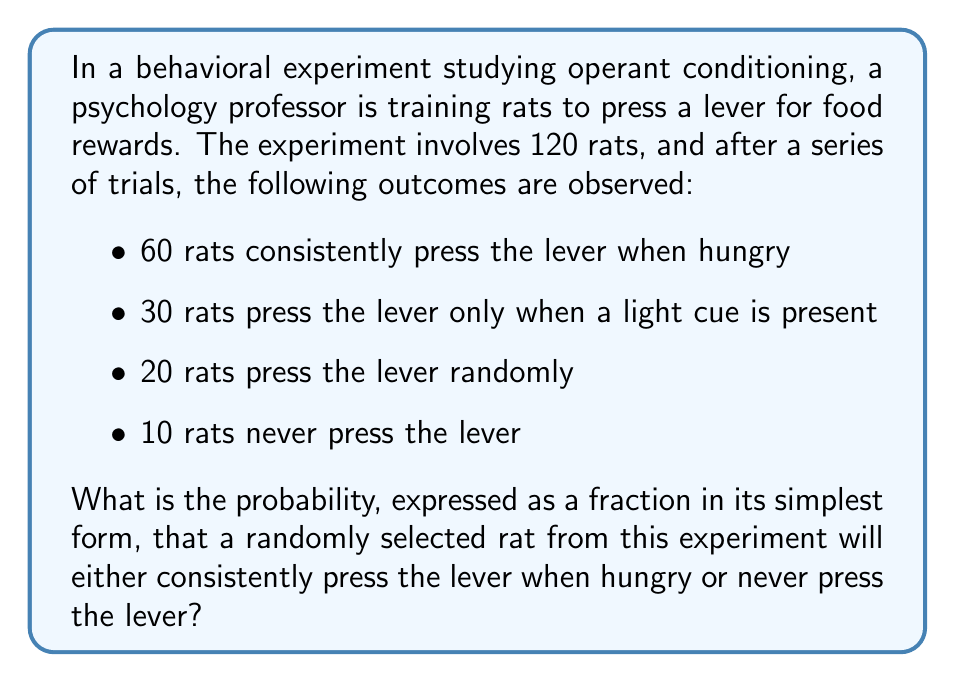Can you solve this math problem? To solve this problem, we need to follow these steps:

1. Identify the total number of rats in the experiment:
   Total rats = 120

2. Identify the number of rats that meet our criteria:
   - Rats that consistently press the lever when hungry: 60
   - Rats that never press the lever: 10
   
   Total rats meeting our criteria = 60 + 10 = 70

3. Calculate the probability using the formula:
   $$P(\text{event}) = \frac{\text{number of favorable outcomes}}{\text{total number of possible outcomes}}$$

   In this case:
   $$P(\text{consistent or never}) = \frac{\text{rats that consistently press or never press}}{\text{total rats}}$$

   $$P(\text{consistent or never}) = \frac{70}{120}$$

4. Simplify the fraction:
   To simplify $\frac{70}{120}$, we can divide both the numerator and denominator by their greatest common divisor (GCD).
   The GCD of 70 and 120 is 10.

   $$\frac{70 \div 10}{120 \div 10} = \frac{7}{12}$$

Thus, the probability of selecting a rat that either consistently presses the lever when hungry or never presses the lever is $\frac{7}{12}$.
Answer: $\frac{7}{12}$ 